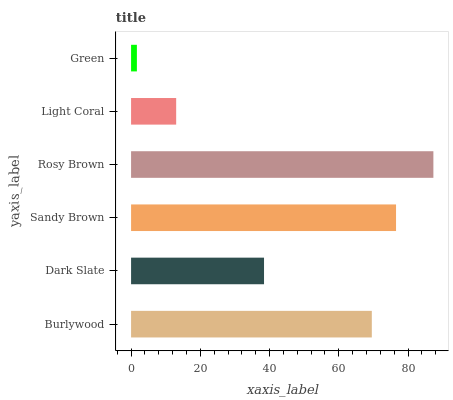Is Green the minimum?
Answer yes or no. Yes. Is Rosy Brown the maximum?
Answer yes or no. Yes. Is Dark Slate the minimum?
Answer yes or no. No. Is Dark Slate the maximum?
Answer yes or no. No. Is Burlywood greater than Dark Slate?
Answer yes or no. Yes. Is Dark Slate less than Burlywood?
Answer yes or no. Yes. Is Dark Slate greater than Burlywood?
Answer yes or no. No. Is Burlywood less than Dark Slate?
Answer yes or no. No. Is Burlywood the high median?
Answer yes or no. Yes. Is Dark Slate the low median?
Answer yes or no. Yes. Is Rosy Brown the high median?
Answer yes or no. No. Is Rosy Brown the low median?
Answer yes or no. No. 